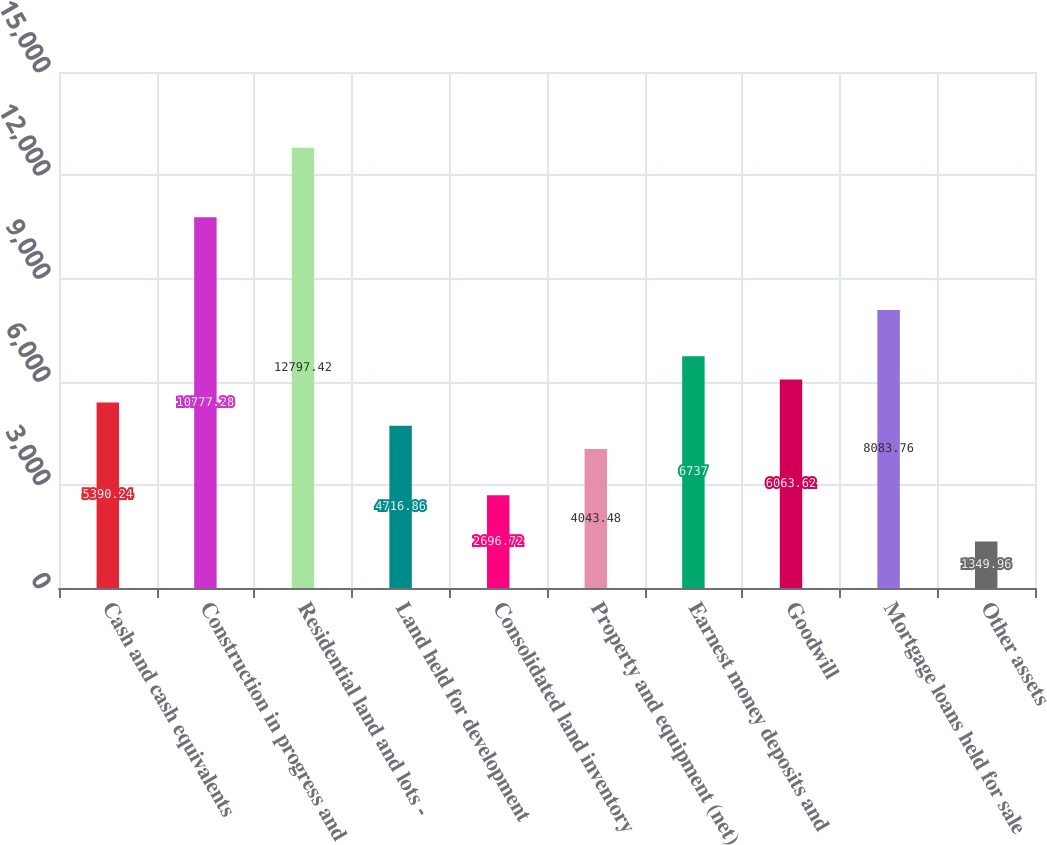Convert chart. <chart><loc_0><loc_0><loc_500><loc_500><bar_chart><fcel>Cash and cash equivalents<fcel>Construction in progress and<fcel>Residential land and lots -<fcel>Land held for development<fcel>Consolidated land inventory<fcel>Property and equipment (net)<fcel>Earnest money deposits and<fcel>Goodwill<fcel>Mortgage loans held for sale<fcel>Other assets<nl><fcel>5390.24<fcel>10777.3<fcel>12797.4<fcel>4716.86<fcel>2696.72<fcel>4043.48<fcel>6737<fcel>6063.62<fcel>8083.76<fcel>1349.96<nl></chart> 